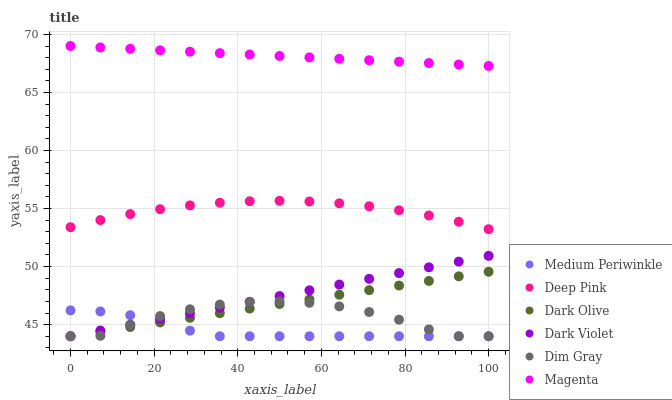Does Medium Periwinkle have the minimum area under the curve?
Answer yes or no. Yes. Does Magenta have the maximum area under the curve?
Answer yes or no. Yes. Does Dark Olive have the minimum area under the curve?
Answer yes or no. No. Does Dark Olive have the maximum area under the curve?
Answer yes or no. No. Is Dark Olive the smoothest?
Answer yes or no. Yes. Is Dim Gray the roughest?
Answer yes or no. Yes. Is Medium Periwinkle the smoothest?
Answer yes or no. No. Is Medium Periwinkle the roughest?
Answer yes or no. No. Does Dim Gray have the lowest value?
Answer yes or no. Yes. Does Deep Pink have the lowest value?
Answer yes or no. No. Does Magenta have the highest value?
Answer yes or no. Yes. Does Dark Olive have the highest value?
Answer yes or no. No. Is Dark Olive less than Magenta?
Answer yes or no. Yes. Is Magenta greater than Deep Pink?
Answer yes or no. Yes. Does Dim Gray intersect Dark Violet?
Answer yes or no. Yes. Is Dim Gray less than Dark Violet?
Answer yes or no. No. Is Dim Gray greater than Dark Violet?
Answer yes or no. No. Does Dark Olive intersect Magenta?
Answer yes or no. No. 